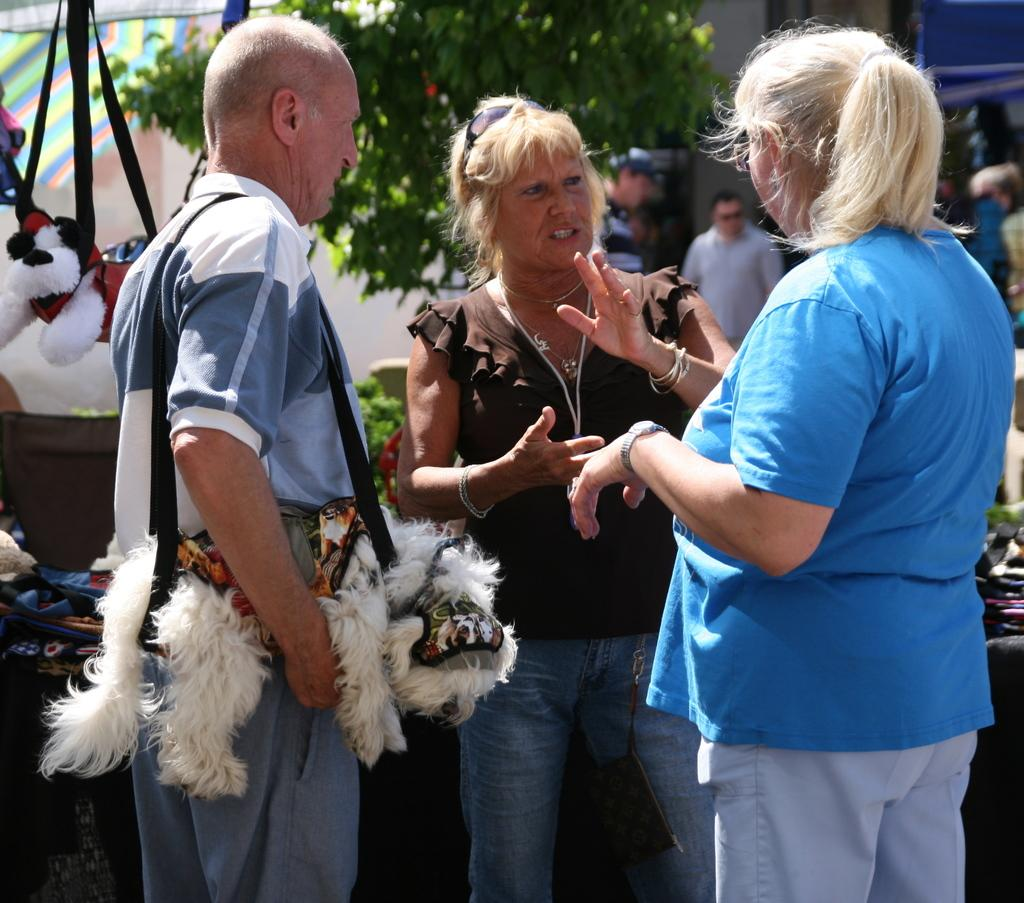How many people are in the image? There is a group of people in the image. What are the people in the image doing? The people are standing in the image. What might the people be engaged in based on their actions? The people are speaking together in the image. What type of rest can be seen in the image? There is no rest visible in the image; it features a group of people standing and speaking together. What type of duck can be seen in the image? There is no duck present in the image. 